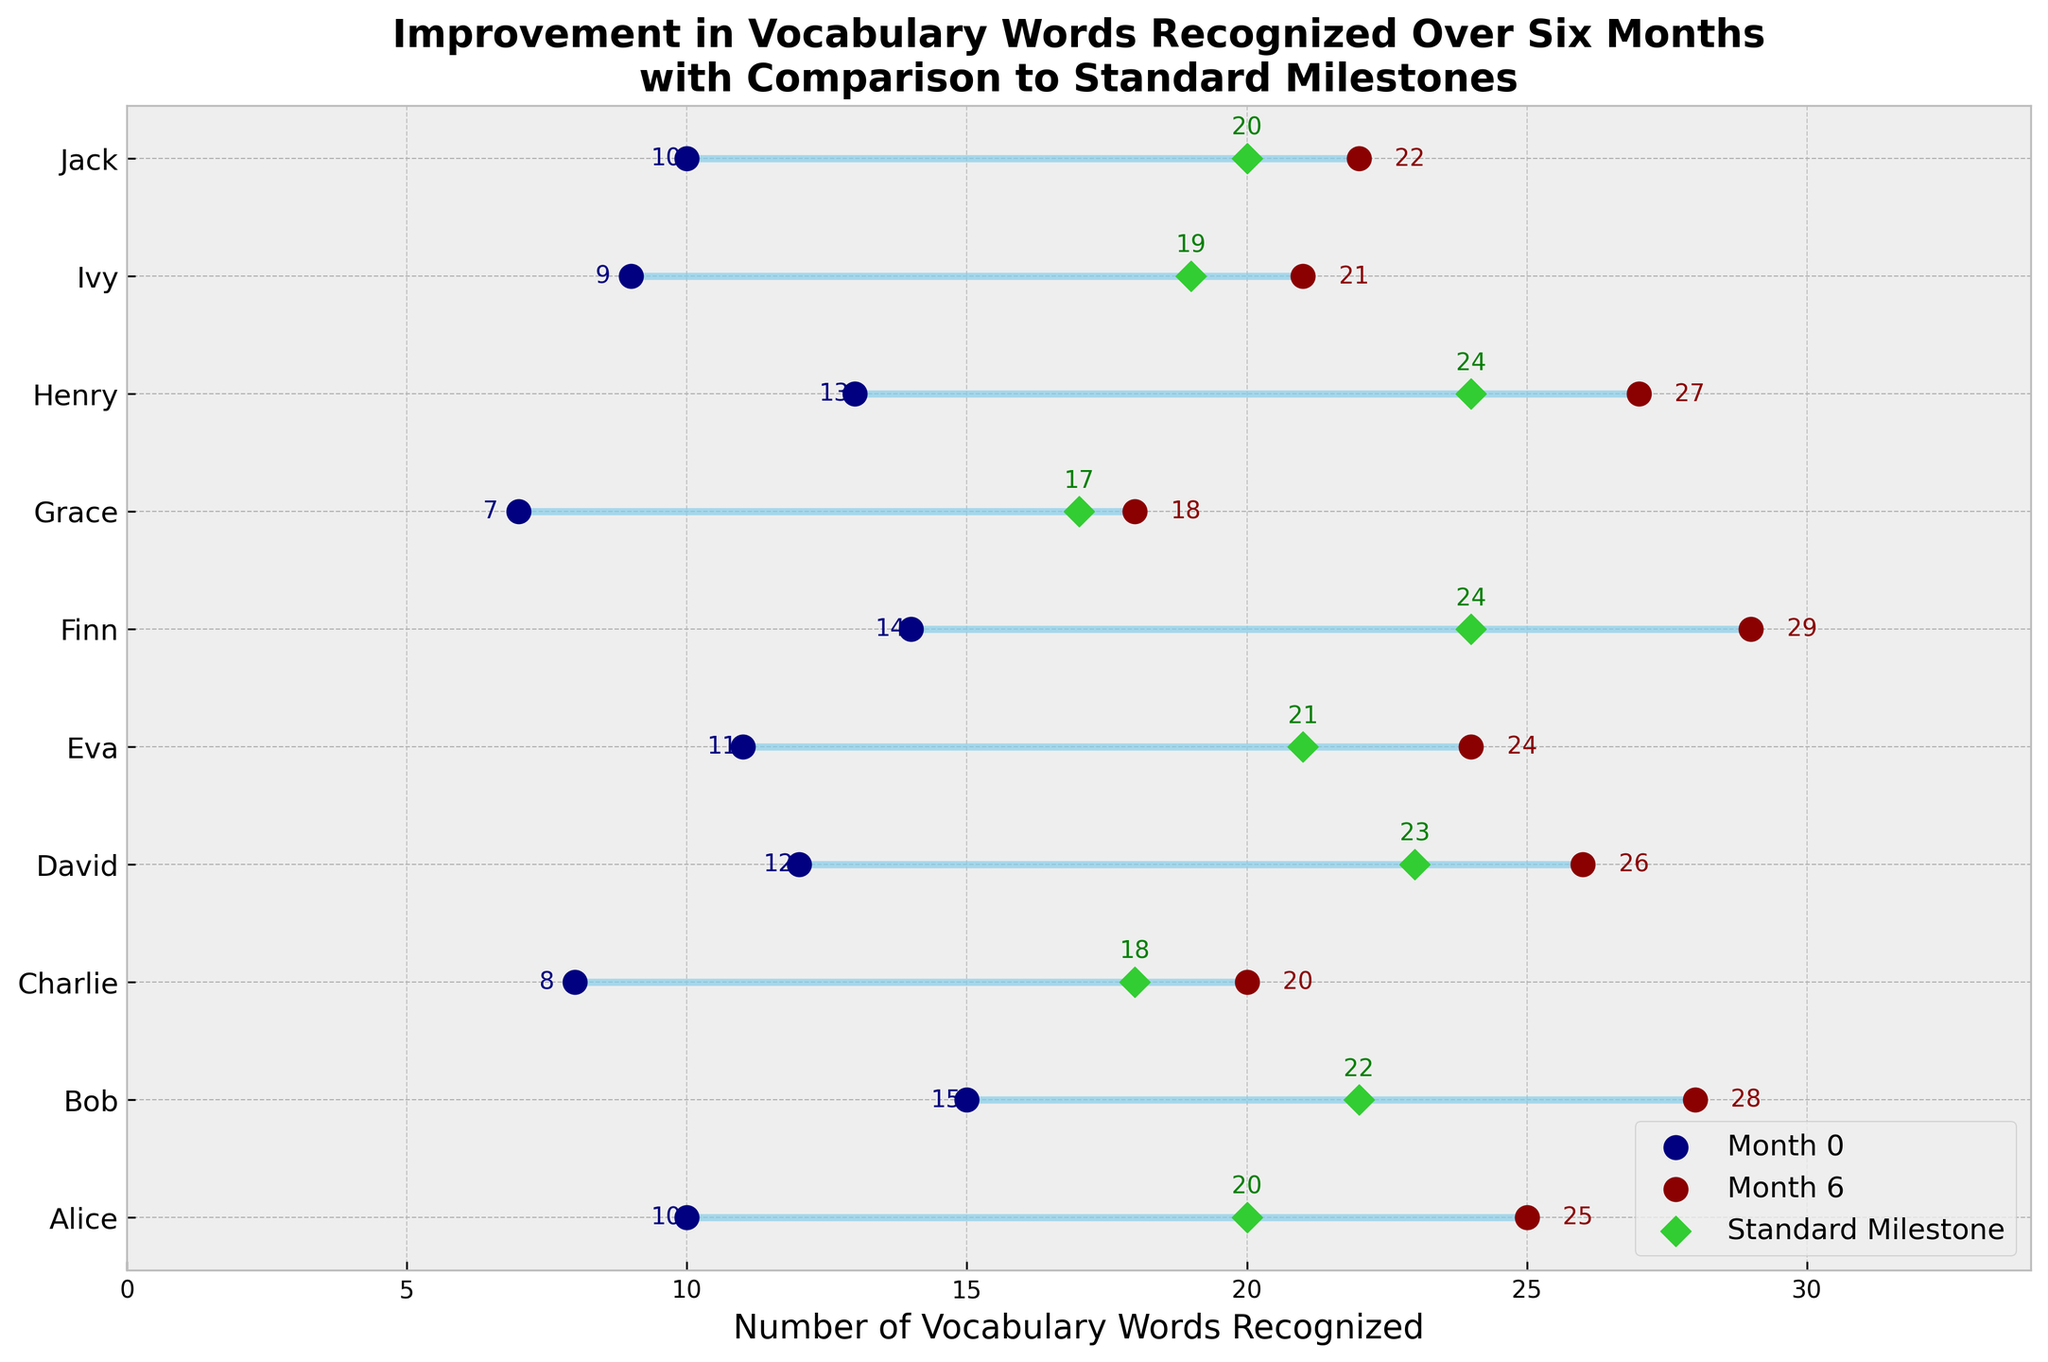How many participants are included in the study? Count the number of unique names listed on the y-axis of the plot. The figure shows 10 participants: Alice, Bob, Charlie, David, Eva, Finn, Grace, Henry, Ivy, and Jack.
Answer: 10 What is the title of the plot? Read the title found at the top of the plot. The title is "Improvement in Vocabulary Words Recognized Over Six Months with Comparison to Standard Milestones."
Answer: Improvement in Vocabulary Words Recognized Over Six Months with Comparison to Standard Milestones Which participant recognized the most vocabulary words at Month 6? Look at the values at the end of each dumbbell line. Finn has the highest value at Month 6, which is 29.
Answer: Finn Who had the smallest improvement from Month 0 to Month 6? Calculate the difference between Month 6 and Month 0 for each participant and find the smallest value: Alice (+15), Bob (+13), Charlie (+12), David (+14), Eva (+13), Finn (+15), Grace (+11), Henry (+14), Ivy (+12), Jack (+12). Grace has the smallest improvement with +11.
Answer: Grace Which participant surpassed the Standard Milestone by the largest margin? Subtract the Standard Milestone from the Month 6 value for each participant and find the largest difference: Alice (+5), Bob (+6), Charlie (+2), David (+3), Eva (+3), Finn (+5), Grace (+1), Henry (+3), Ivy (+2), Jack (+2). Bob surpassed the milestone by the largest margin with +6.
Answer: Bob How many participants achieved the Standard Milestone by Month 6? Compare values at Month 6 with the Standard Milestone. Alice (25>20), Bob (28>22), Charlie (20>18), David (26>23), Eva (24>21), Finn (29>24), Grace (18=17), Henry (27>24), Ivy (21>19), Jack (22>20). All participants achieved or surpassed the milestone.
Answer: 10 Which participant was closest to the Standard Milestone at Month 6 without exceeding it? Check who achieved a Month 6 value equal to the Standard Milestone: Grace (18<17), all others exceeded it. Ivy (21), closest but actually surpasses by only 2, is a reasonable proxy if not purely 'without exceeding'.
Answer: Ivy How many more vocabulary words did Bob recognize at Month 6 compared to Month 0? Subtract Bob's Month 0 value from his Month 6 value: 28 - 15 = 13.
Answer: 13 For which participant was the initial vocabulary word count (Month 0) closest to the Standard Milestone? Compare Month 0 values with Standard Milestone for each participant: Alice (10<20), Bob (15<22), Charlie (8<18), David (12<23), Eva (11<21), Finn (14<24), Grace (7<17), Henry (13<24), Ivy (9<19), Jack (10<20). Jack and Alice are both 10, closest to 20.
Answer: Jack and Alice What is the average number of vocabulary words recognized at Month 0 across all participants? Sum all Month 0 values and divide by the number of participants: (10+15+8+12+11+14+7+13+9+10)/10 = 99/10 = 9.9.
Answer: 9.9 